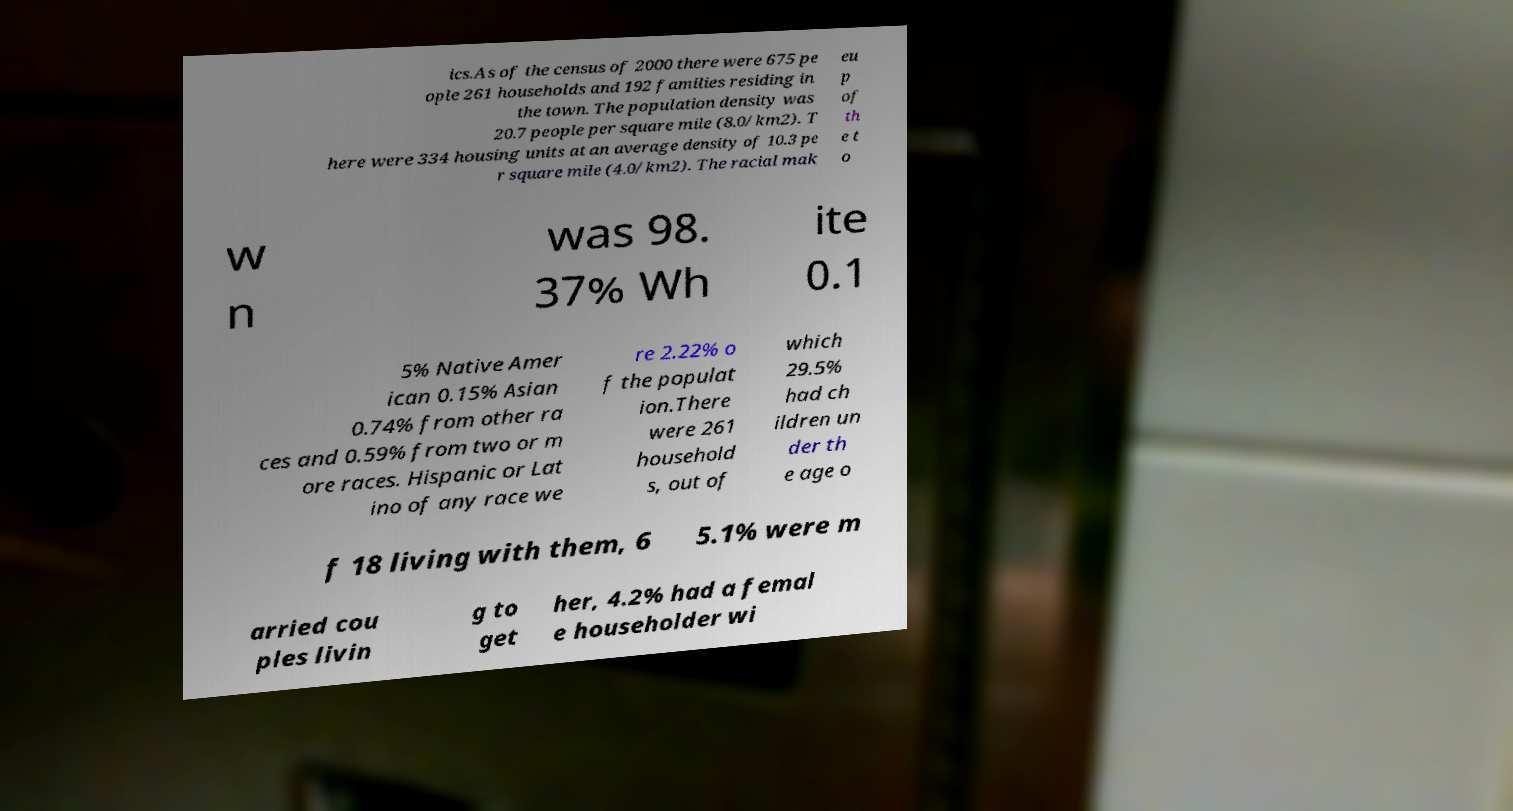Please identify and transcribe the text found in this image. ics.As of the census of 2000 there were 675 pe ople 261 households and 192 families residing in the town. The population density was 20.7 people per square mile (8.0/km2). T here were 334 housing units at an average density of 10.3 pe r square mile (4.0/km2). The racial mak eu p of th e t o w n was 98. 37% Wh ite 0.1 5% Native Amer ican 0.15% Asian 0.74% from other ra ces and 0.59% from two or m ore races. Hispanic or Lat ino of any race we re 2.22% o f the populat ion.There were 261 household s, out of which 29.5% had ch ildren un der th e age o f 18 living with them, 6 5.1% were m arried cou ples livin g to get her, 4.2% had a femal e householder wi 